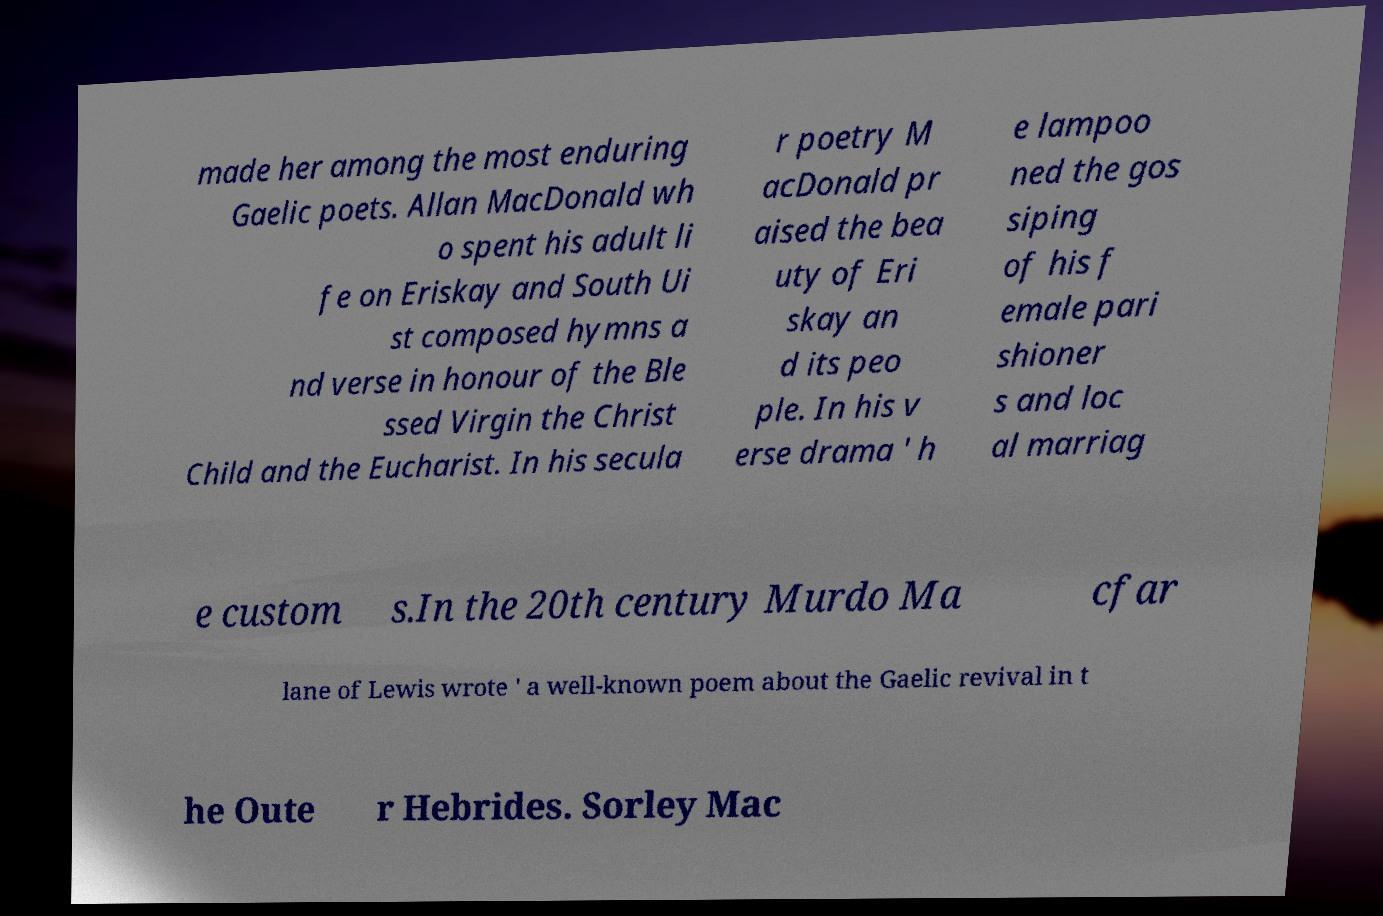Please read and relay the text visible in this image. What does it say? made her among the most enduring Gaelic poets. Allan MacDonald wh o spent his adult li fe on Eriskay and South Ui st composed hymns a nd verse in honour of the Ble ssed Virgin the Christ Child and the Eucharist. In his secula r poetry M acDonald pr aised the bea uty of Eri skay an d its peo ple. In his v erse drama ' h e lampoo ned the gos siping of his f emale pari shioner s and loc al marriag e custom s.In the 20th century Murdo Ma cfar lane of Lewis wrote ' a well-known poem about the Gaelic revival in t he Oute r Hebrides. Sorley Mac 